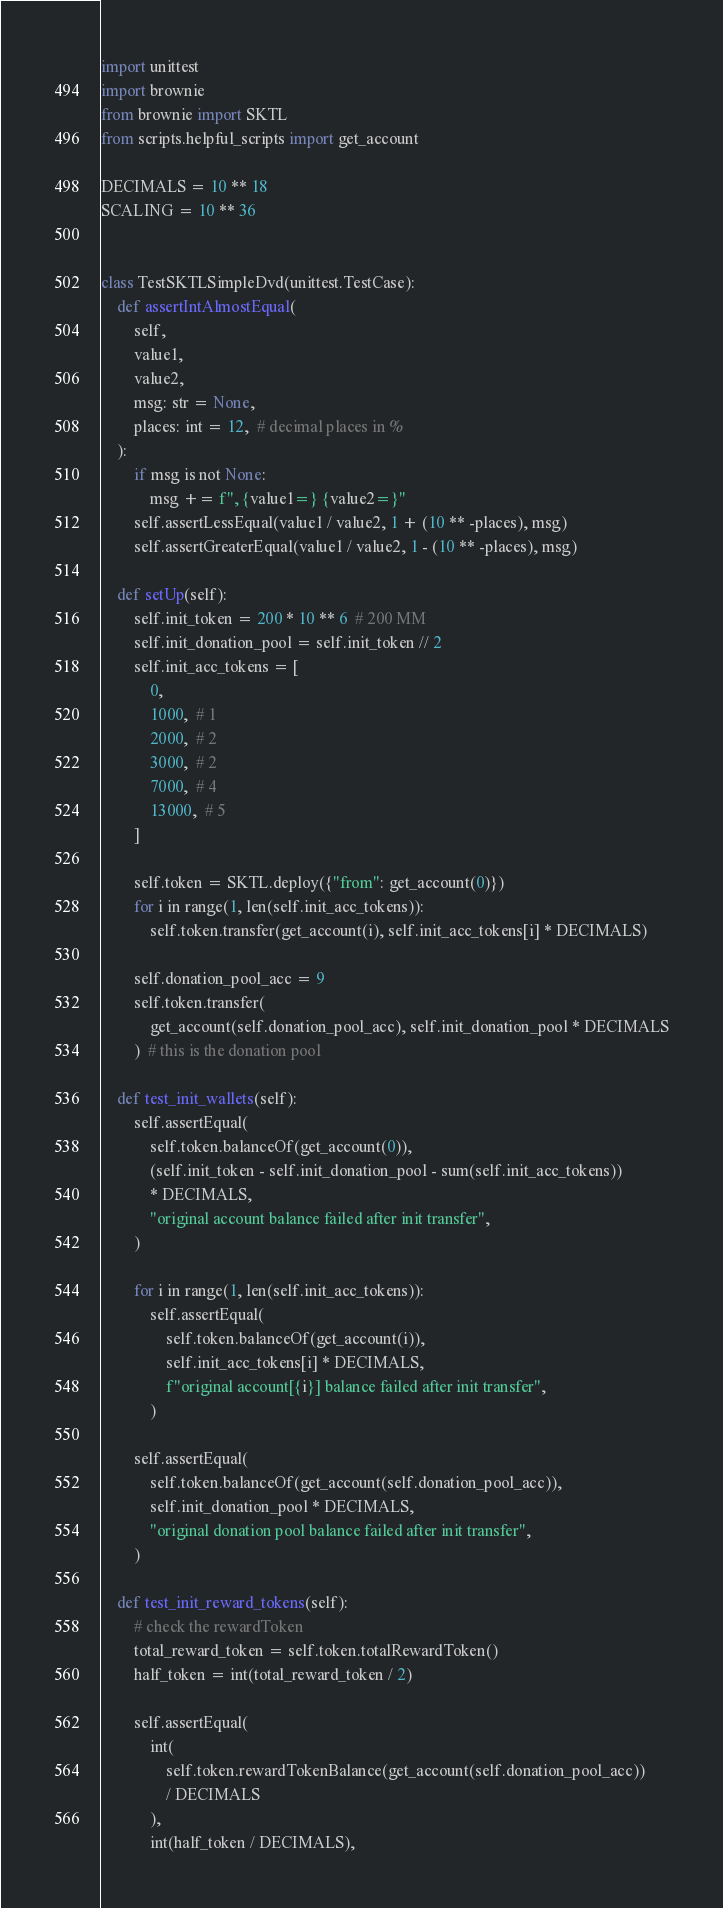<code> <loc_0><loc_0><loc_500><loc_500><_Python_>import unittest
import brownie
from brownie import SKTL
from scripts.helpful_scripts import get_account

DECIMALS = 10 ** 18
SCALING = 10 ** 36


class TestSKTLSimpleDvd(unittest.TestCase):
    def assertIntAlmostEqual(
        self,
        value1,
        value2,
        msg: str = None,
        places: int = 12,  # decimal places in %
    ):
        if msg is not None:
            msg += f", {value1=} {value2=}"
        self.assertLessEqual(value1 / value2, 1 + (10 ** -places), msg)
        self.assertGreaterEqual(value1 / value2, 1 - (10 ** -places), msg)

    def setUp(self):
        self.init_token = 200 * 10 ** 6  # 200 MM
        self.init_donation_pool = self.init_token // 2
        self.init_acc_tokens = [
            0,
            1000,  # 1
            2000,  # 2
            3000,  # 2
            7000,  # 4
            13000,  # 5
        ]

        self.token = SKTL.deploy({"from": get_account(0)})
        for i in range(1, len(self.init_acc_tokens)):
            self.token.transfer(get_account(i), self.init_acc_tokens[i] * DECIMALS)

        self.donation_pool_acc = 9
        self.token.transfer(
            get_account(self.donation_pool_acc), self.init_donation_pool * DECIMALS
        )  # this is the donation pool

    def test_init_wallets(self):
        self.assertEqual(
            self.token.balanceOf(get_account(0)),
            (self.init_token - self.init_donation_pool - sum(self.init_acc_tokens))
            * DECIMALS,
            "original account balance failed after init transfer",
        )

        for i in range(1, len(self.init_acc_tokens)):
            self.assertEqual(
                self.token.balanceOf(get_account(i)),
                self.init_acc_tokens[i] * DECIMALS,
                f"original account[{i}] balance failed after init transfer",
            )

        self.assertEqual(
            self.token.balanceOf(get_account(self.donation_pool_acc)),
            self.init_donation_pool * DECIMALS,
            "original donation pool balance failed after init transfer",
        )

    def test_init_reward_tokens(self):
        # check the rewardToken
        total_reward_token = self.token.totalRewardToken()
        half_token = int(total_reward_token / 2)

        self.assertEqual(
            int(
                self.token.rewardTokenBalance(get_account(self.donation_pool_acc))
                / DECIMALS
            ),
            int(half_token / DECIMALS),</code> 